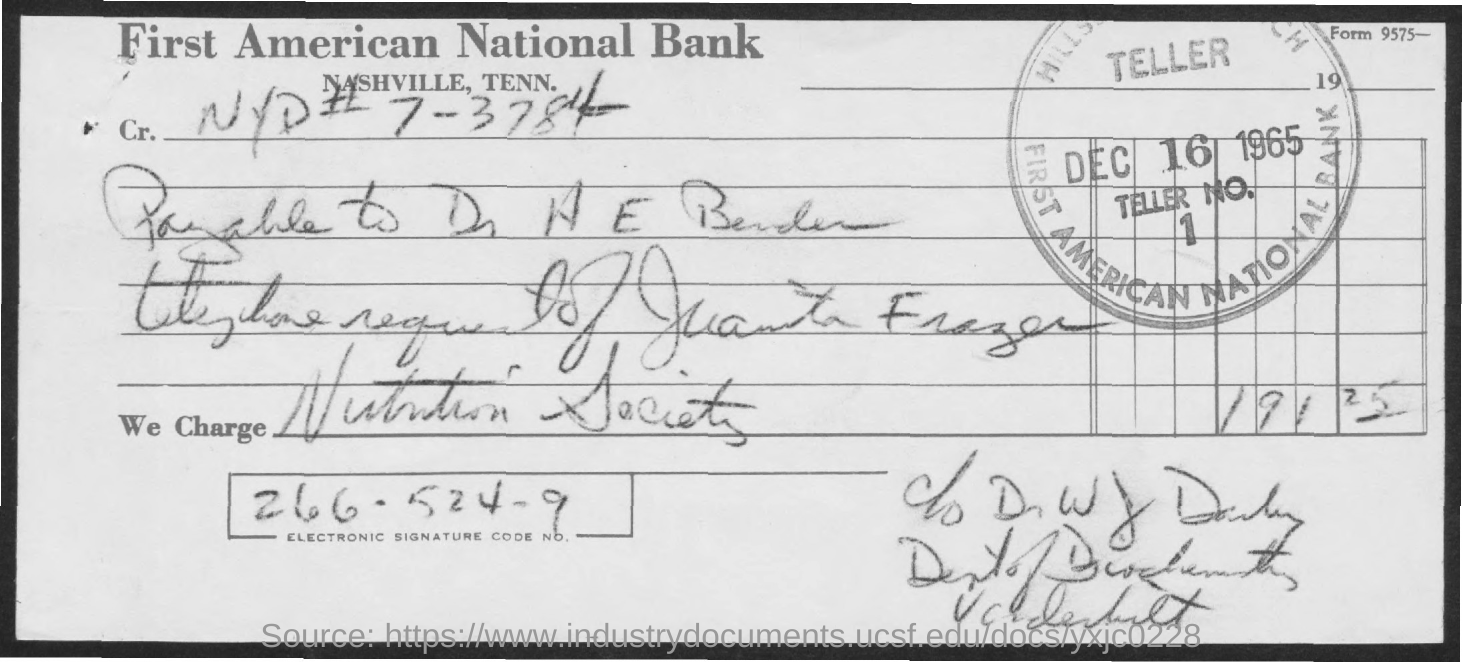Mention a couple of crucial points in this snapshot. The document indicates that the date is December 16, 1965. The amount is 191 with a decimal point and 25 without a decimal point. What is the electronic signature code number?" can be converted to "Can you please provide the electronic signature code? The Nutrition Society is facing charges. 